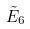<formula> <loc_0><loc_0><loc_500><loc_500>\tilde { E } _ { 6 }</formula> 